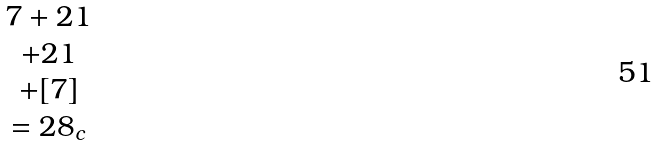Convert formula to latex. <formula><loc_0><loc_0><loc_500><loc_500>\begin{matrix} 7 + 2 1 \\ + 2 1 \\ + [ 7 ] \\ = { 2 8 } _ { c } \end{matrix}</formula> 